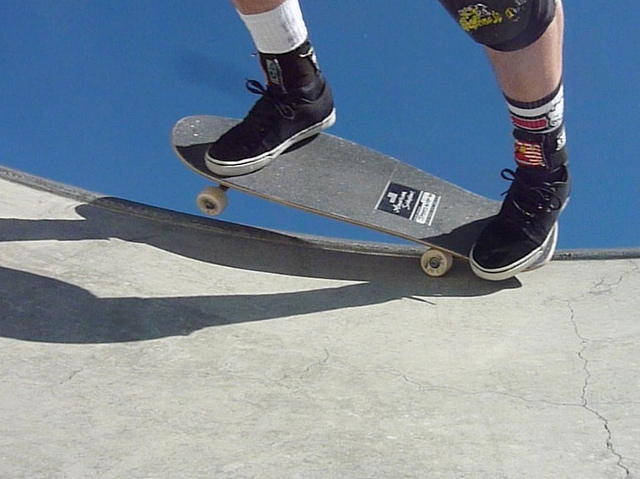<image>What kind of traction do the wheels have on this skateboard in the photo? It is uncertain what kind of traction the wheels have on this skateboard. It might be smooth, have a little or even be limited. What kind of traction do the wheels have on this skateboard in the photo? It is ambiguous what kind of traction the wheels have on the skateboard in the photo. It can be seen as having little or smooth traction. 